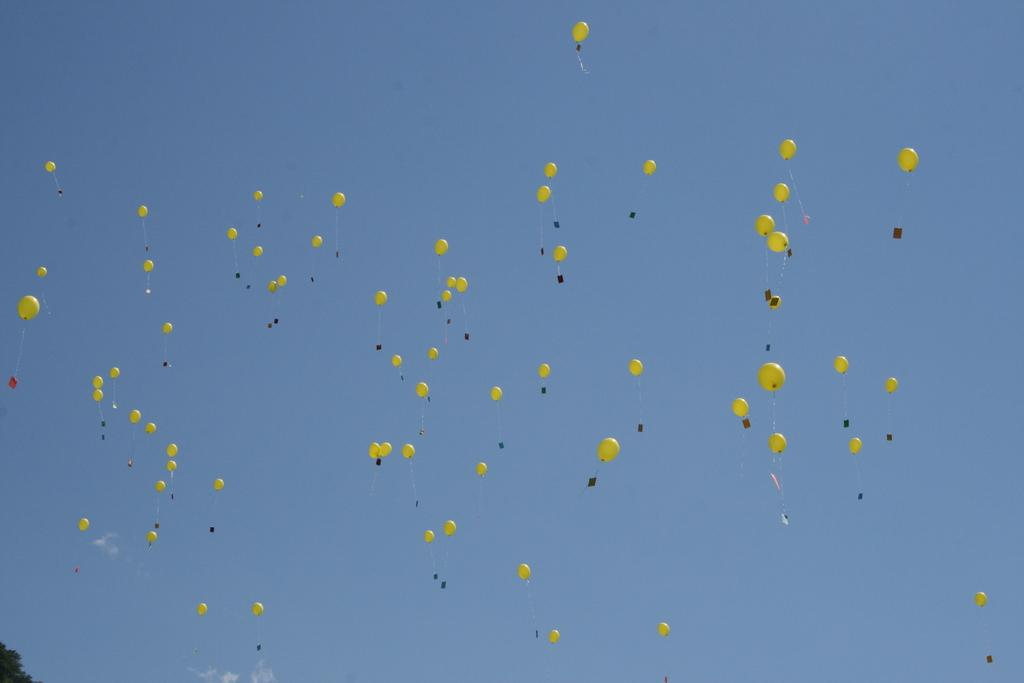What color are the balloons in the image? The balloons in the image are yellow in color. What are the balloons doing in the image? The balloons are flying in the air. What can be seen in the background of the image? The sky is visible in the background of the image. What is the color of the sky in the image? The sky is blue in color. Are there any other objects visible in the image besides the balloons? Yes, a few leaves are visible in the bottom left-hand corner of the image. How many nails are holding the cobweb in the image? There is no cobweb or nails present in the image. 